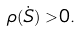<formula> <loc_0><loc_0><loc_500><loc_500>\rho ( \dot { S } ) > 0 .</formula> 